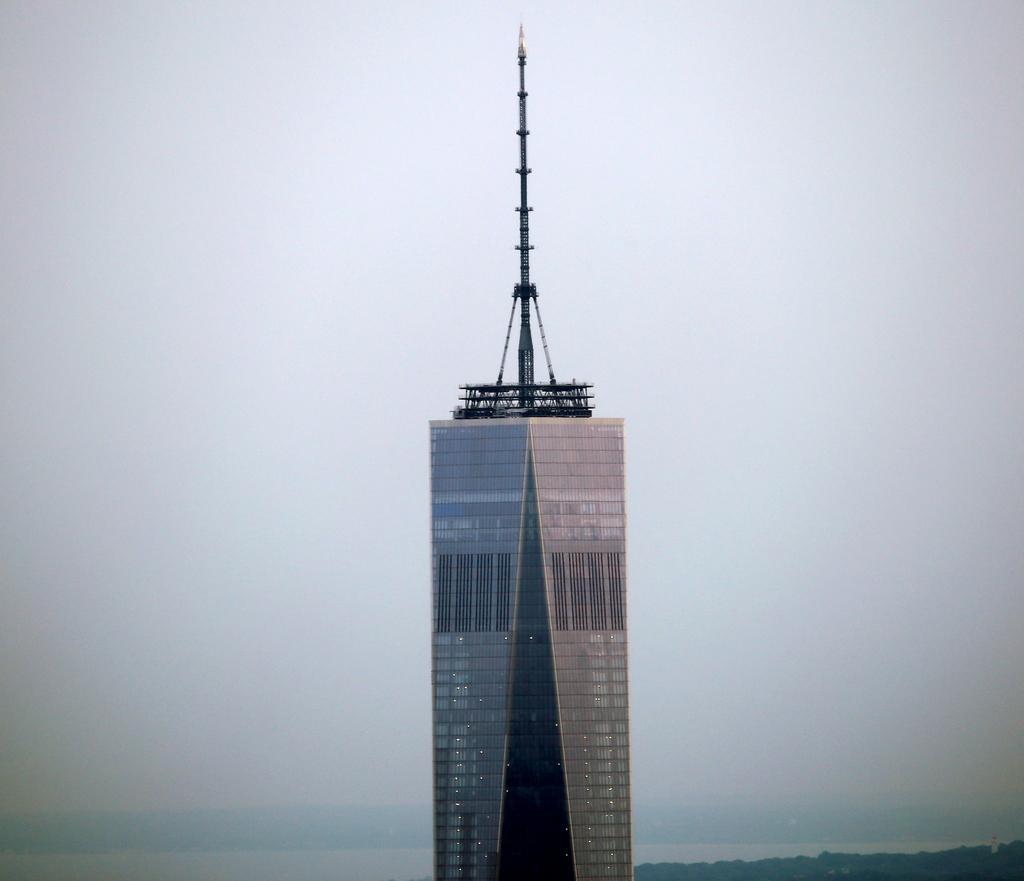Please provide a concise description of this image. This picture shows a building and we see a cloudy Sky. 